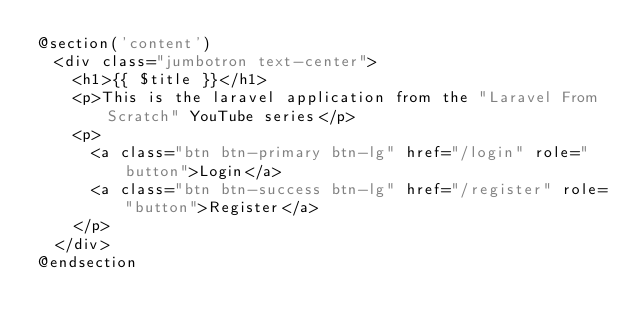<code> <loc_0><loc_0><loc_500><loc_500><_PHP_>@section('content')
  <div class="jumbotron text-center">
    <h1>{{ $title }}</h1>
    <p>This is the laravel application from the "Laravel From Scratch" YouTube series</p>
    <p>
      <a class="btn btn-primary btn-lg" href="/login" role="button">Login</a>
      <a class="btn btn-success btn-lg" href="/register" role="button">Register</a>
    </p>
  </div>
@endsection</code> 